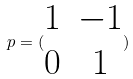<formula> <loc_0><loc_0><loc_500><loc_500>p = ( \begin{matrix} 1 & - 1 \\ 0 & 1 \end{matrix} )</formula> 